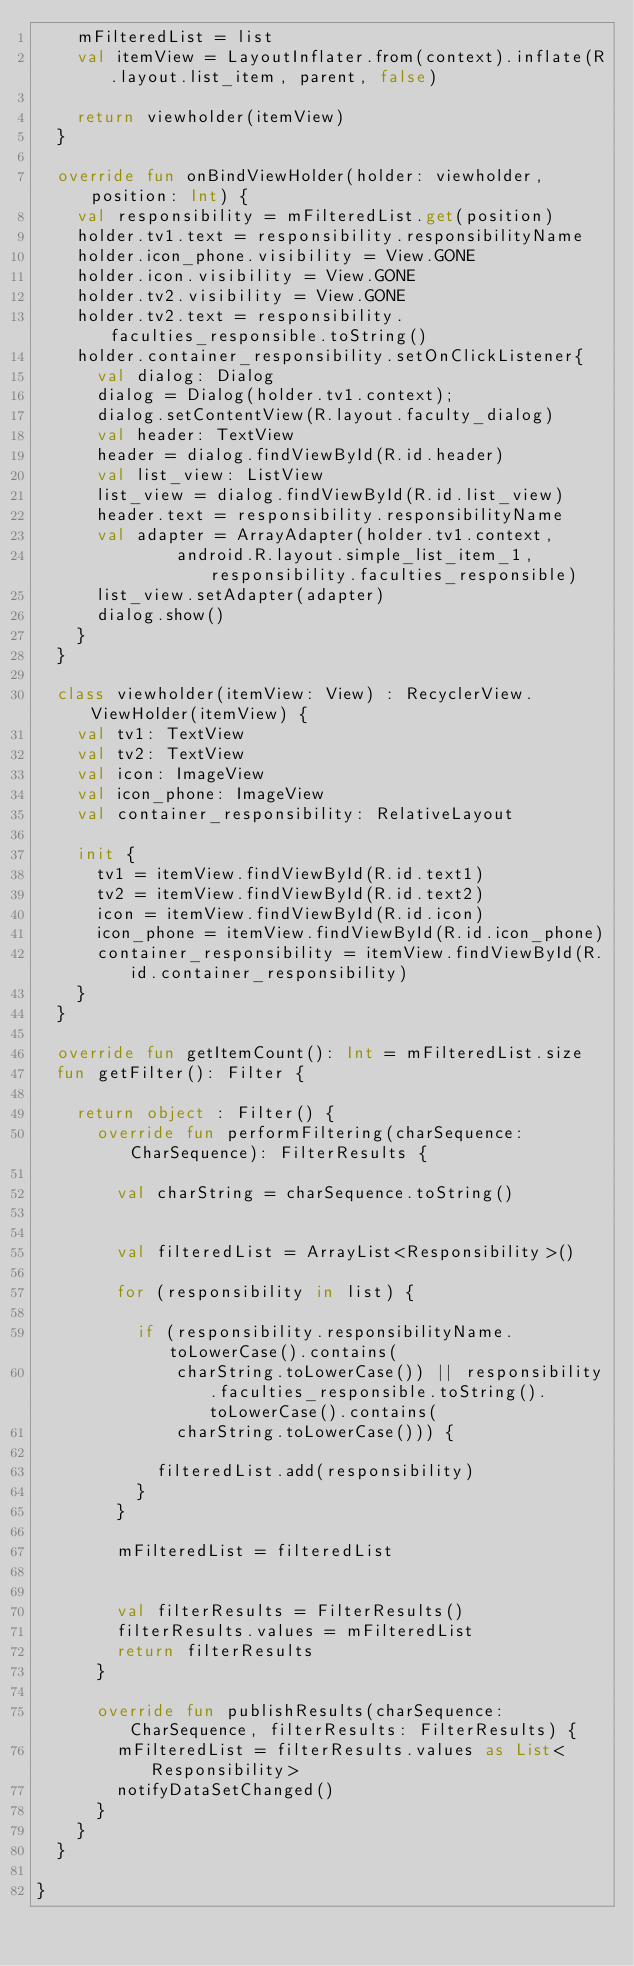<code> <loc_0><loc_0><loc_500><loc_500><_Kotlin_>    mFilteredList = list
    val itemView = LayoutInflater.from(context).inflate(R.layout.list_item, parent, false)

    return viewholder(itemView)
  }

  override fun onBindViewHolder(holder: viewholder, position: Int) {
    val responsibility = mFilteredList.get(position)
    holder.tv1.text = responsibility.responsibilityName
    holder.icon_phone.visibility = View.GONE
    holder.icon.visibility = View.GONE
    holder.tv2.visibility = View.GONE
    holder.tv2.text = responsibility.faculties_responsible.toString()
    holder.container_responsibility.setOnClickListener{
      val dialog: Dialog
      dialog = Dialog(holder.tv1.context);
      dialog.setContentView(R.layout.faculty_dialog)
      val header: TextView
      header = dialog.findViewById(R.id.header)
      val list_view: ListView
      list_view = dialog.findViewById(R.id.list_view)
      header.text = responsibility.responsibilityName
      val adapter = ArrayAdapter(holder.tv1.context,
              android.R.layout.simple_list_item_1, responsibility.faculties_responsible)
      list_view.setAdapter(adapter)
      dialog.show()
    }
  }

  class viewholder(itemView: View) : RecyclerView.ViewHolder(itemView) {
    val tv1: TextView
    val tv2: TextView
    val icon: ImageView
    val icon_phone: ImageView
    val container_responsibility: RelativeLayout

    init {
      tv1 = itemView.findViewById(R.id.text1)
      tv2 = itemView.findViewById(R.id.text2)
      icon = itemView.findViewById(R.id.icon)
      icon_phone = itemView.findViewById(R.id.icon_phone)
      container_responsibility = itemView.findViewById(R.id.container_responsibility)
    }
  }

  override fun getItemCount(): Int = mFilteredList.size
  fun getFilter(): Filter {

    return object : Filter() {
      override fun performFiltering(charSequence: CharSequence): FilterResults {

        val charString = charSequence.toString()


        val filteredList = ArrayList<Responsibility>()

        for (responsibility in list) {

          if (responsibility.responsibilityName.toLowerCase().contains(
              charString.toLowerCase()) || responsibility.faculties_responsible.toString().toLowerCase().contains(
              charString.toLowerCase())) {

            filteredList.add(responsibility)
          }
        }

        mFilteredList = filteredList


        val filterResults = FilterResults()
        filterResults.values = mFilteredList
        return filterResults
      }

      override fun publishResults(charSequence: CharSequence, filterResults: FilterResults) {
        mFilteredList = filterResults.values as List<Responsibility>
        notifyDataSetChanged()
      }
    }
  }

}
</code> 